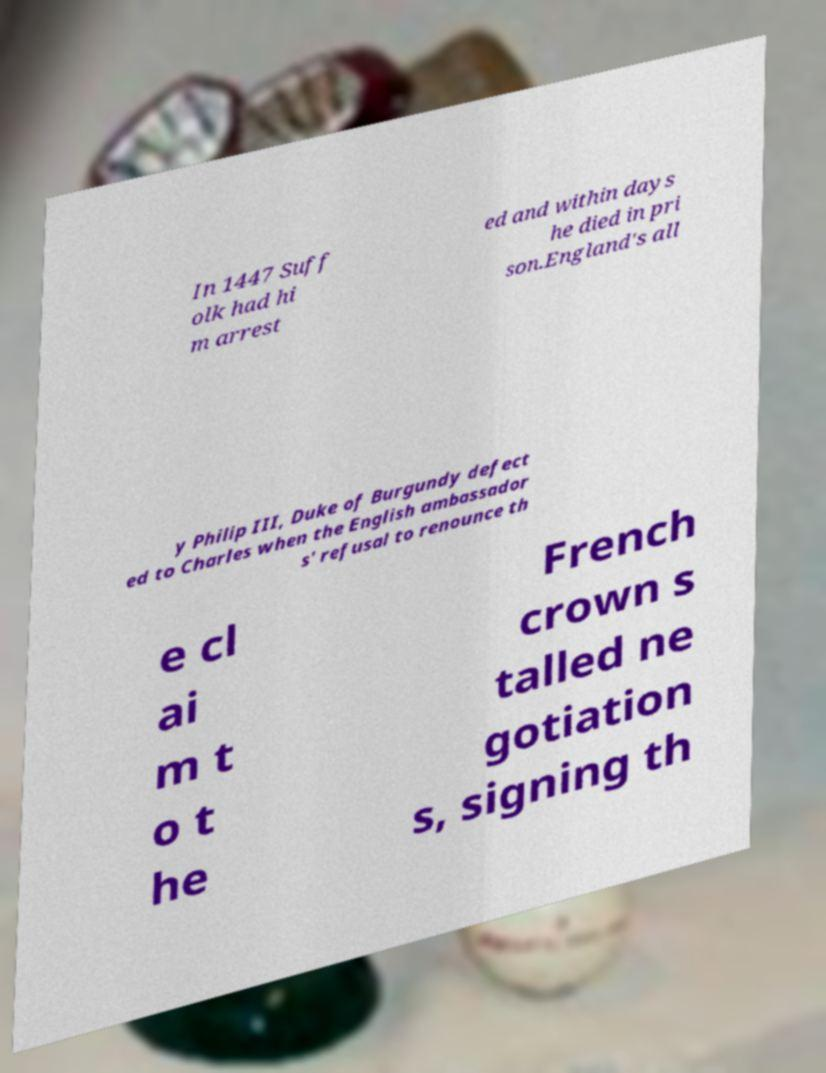Could you assist in decoding the text presented in this image and type it out clearly? In 1447 Suff olk had hi m arrest ed and within days he died in pri son.England's all y Philip III, Duke of Burgundy defect ed to Charles when the English ambassador s' refusal to renounce th e cl ai m t o t he French crown s talled ne gotiation s, signing th 